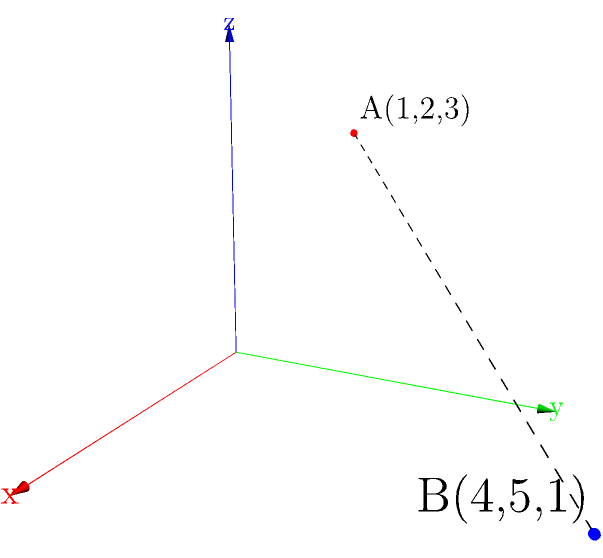In a 3D game environment, two game objects are located at points A(1,2,3) and B(4,5,1). Calculate the distance between these two objects using the distance formula in three-dimensional space. Round your answer to two decimal places. To calculate the distance between two points in 3D space, we use the distance formula:

$$ d = \sqrt{(x_2-x_1)^2 + (y_2-y_1)^2 + (z_2-z_1)^2} $$

Where $(x_1,y_1,z_1)$ are the coordinates of the first point and $(x_2,y_2,z_2)$ are the coordinates of the second point.

Let's follow these steps:

1) Identify the coordinates:
   Point A: $(x_1,y_1,z_1) = (1,2,3)$
   Point B: $(x_2,y_2,z_2) = (4,5,1)$

2) Calculate the differences:
   $x_2-x_1 = 4-1 = 3$
   $y_2-y_1 = 5-2 = 3$
   $z_2-z_1 = 1-3 = -2$

3) Square these differences:
   $(x_2-x_1)^2 = 3^2 = 9$
   $(y_2-y_1)^2 = 3^2 = 9$
   $(z_2-z_1)^2 = (-2)^2 = 4$

4) Sum the squared differences:
   $9 + 9 + 4 = 22$

5) Take the square root:
   $\sqrt{22} \approx 4.69$

6) Round to two decimal places:
   $4.69$

Therefore, the distance between the two game objects is approximately 4.69 units.
Answer: 4.69 units 